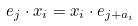Convert formula to latex. <formula><loc_0><loc_0><loc_500><loc_500>e _ { j } \cdot x _ { i } = x _ { i } \cdot e _ { j + a _ { i } }</formula> 